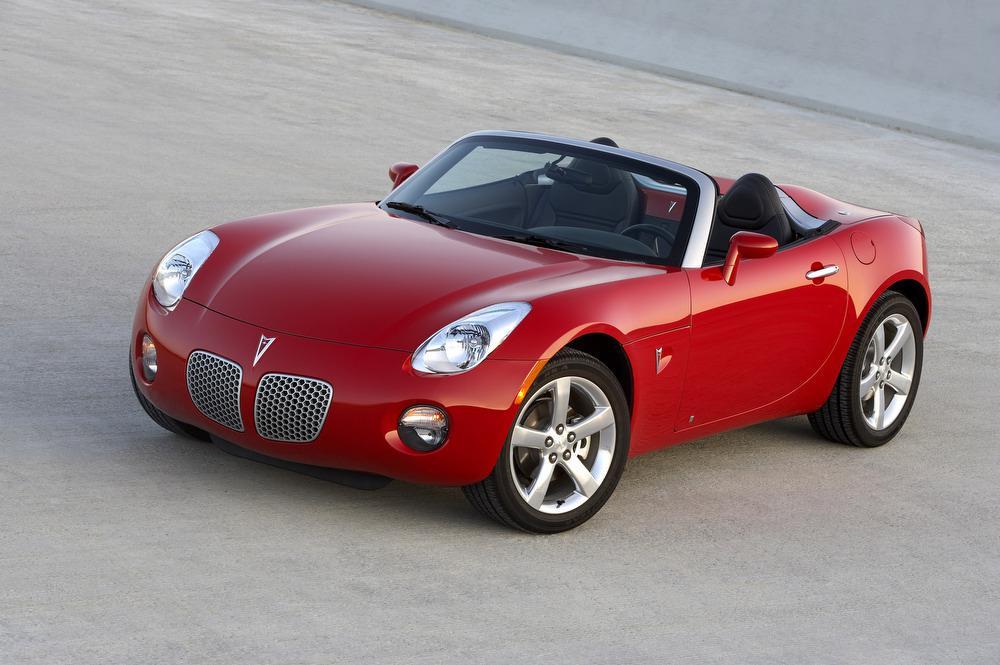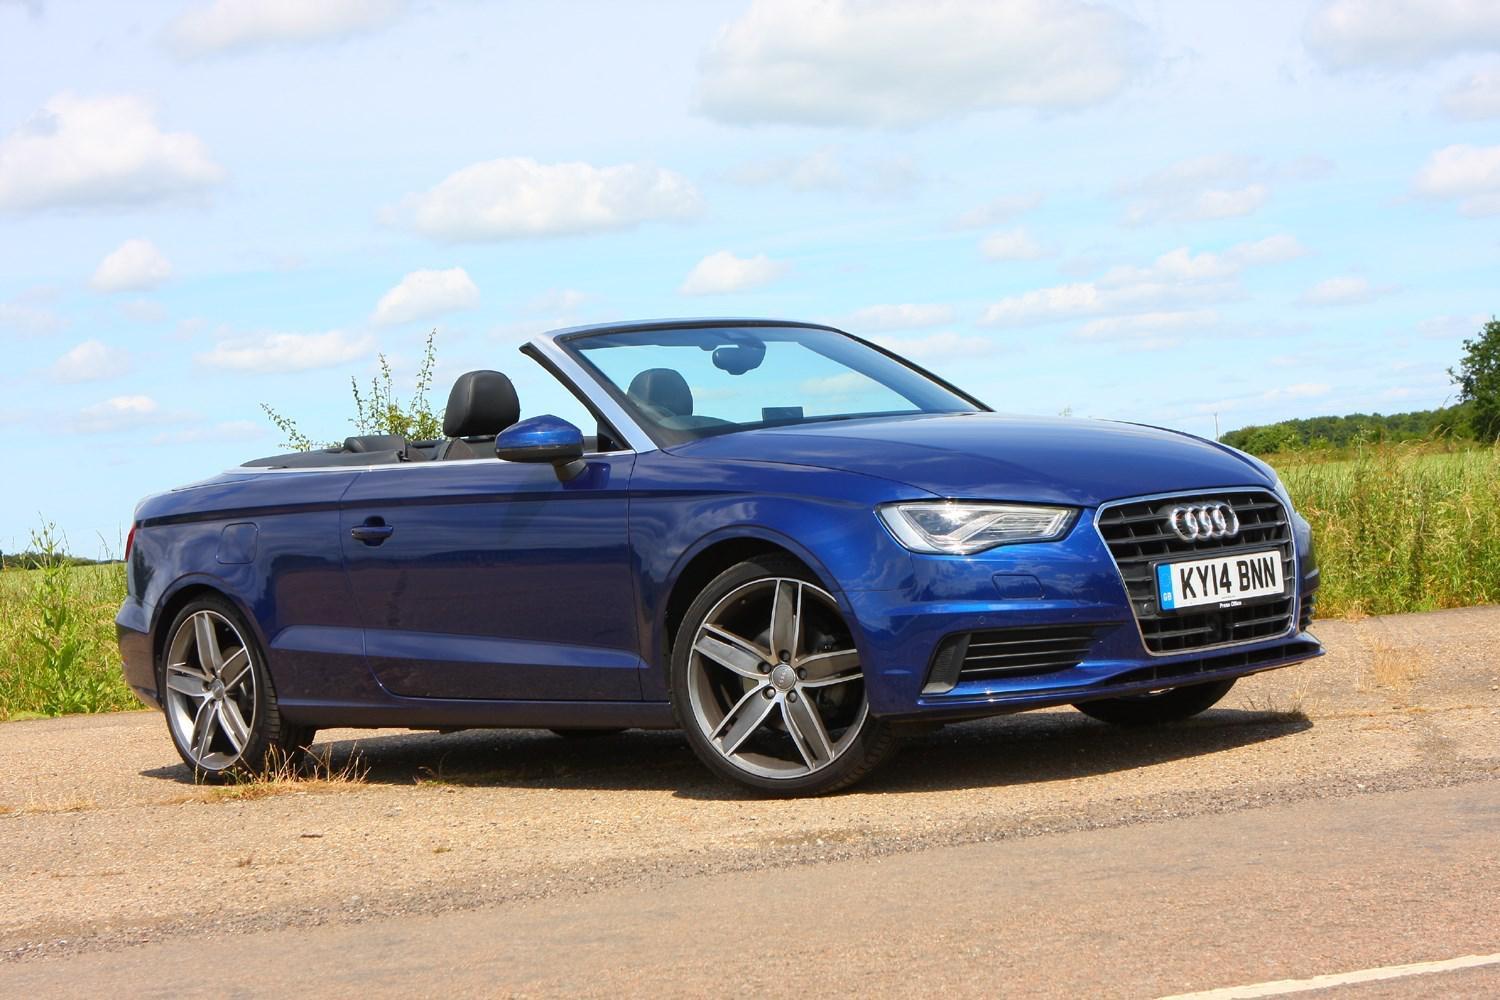The first image is the image on the left, the second image is the image on the right. For the images displayed, is the sentence "One of the convertibles is red." factually correct? Answer yes or no. Yes. The first image is the image on the left, the second image is the image on the right. Given the left and right images, does the statement "There is a red convertible in one image." hold true? Answer yes or no. Yes. The first image is the image on the left, the second image is the image on the right. For the images displayed, is the sentence "a convertible is parked on a sandy lot with grass in the background" factually correct? Answer yes or no. Yes. The first image is the image on the left, the second image is the image on the right. Given the left and right images, does the statement "There is a red convertible car in one image" hold true? Answer yes or no. Yes. 